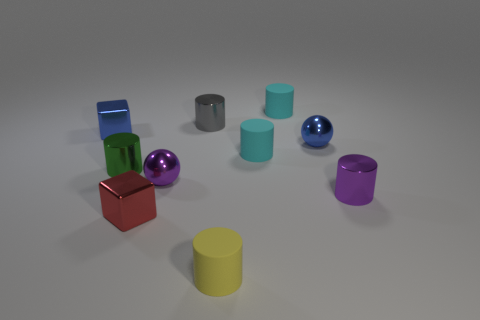Which object stands out the most to you? The red cube stands out due to its vibrant color and the way its geometric shape contrasts with the rounded forms of the nearby objects. Does the color red have any particular meaning in this context? In this context, the red cube's color could simply be a design choice to make it stand out, or it could be intended to evoke strong emotions or draw attention, as red often represents passion, urgency, or importance. 